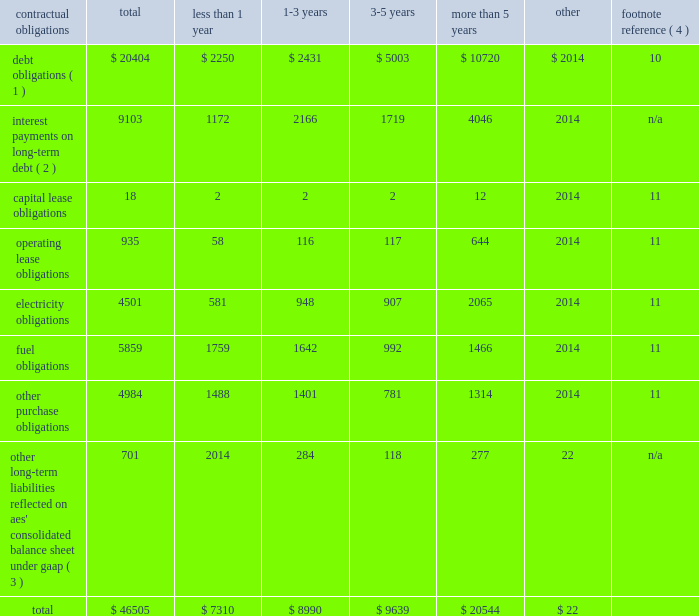2022 triggering our obligation to make payments under any financial guarantee , letter of credit or other credit support we have provided to or on behalf of such subsidiary ; 2022 causing us to record a loss in the event the lender forecloses on the assets ; and 2022 triggering defaults in our outstanding debt at the parent company .
For example , our senior secured credit facility and outstanding debt securities at the parent company include events of default for certain bankruptcy related events involving material subsidiaries .
In addition , our revolving credit agreement at the parent company includes events of default related to payment defaults and accelerations of outstanding debt of material subsidiaries .
Some of our subsidiaries are currently in default with respect to all or a portion of their outstanding indebtedness .
The total non-recourse debt classified as current in the accompanying consolidated balance sheets amounts to $ 2.2 billion .
The portion of current debt related to such defaults was $ 1 billion at december 31 , 2017 , all of which was non-recourse debt related to three subsidiaries 2014 alto maipo , aes puerto rico , and aes ilumina .
See note 10 2014debt in item 8 . 2014financial statements and supplementary data of this form 10-k for additional detail .
None of the subsidiaries that are currently in default are subsidiaries that met the applicable definition of materiality under aes' corporate debt agreements as of december 31 , 2017 in order for such defaults to trigger an event of default or permit acceleration under aes' indebtedness .
However , as a result of additional dispositions of assets , other significant reductions in asset carrying values or other matters in the future that may impact our financial position and results of operations or the financial position of the individual subsidiary , it is possible that one or more of these subsidiaries could fall within the definition of a "material subsidiary" and thereby upon an acceleration trigger an event of default and possible acceleration of the indebtedness under the parent company's outstanding debt securities .
A material subsidiary is defined in the company's senior secured revolving credit facility as any business that contributed 20% ( 20 % ) or more of the parent company's total cash distributions from businesses for the four most recently completed fiscal quarters .
As of december 31 , 2017 , none of the defaults listed above individually or in the aggregate results in or is at risk of triggering a cross-default under the recourse debt of the company .
Contractual obligations and parent company contingent contractual obligations a summary of our contractual obligations , commitments and other liabilities as of december 31 , 2017 is presented below and excludes any businesses classified as discontinued operations or held-for-sale ( in millions ) : contractual obligations total less than 1 year more than 5 years other footnote reference ( 4 ) debt obligations ( 1 ) $ 20404 $ 2250 $ 2431 $ 5003 $ 10720 $ 2014 10 interest payments on long-term debt ( 2 ) 9103 1172 2166 1719 4046 2014 n/a .
_____________________________ ( 1 ) includes recourse and non-recourse debt presented on the consolidated balance sheet .
These amounts exclude capital lease obligations which are included in the capital lease category .
( 2 ) interest payments are estimated based on final maturity dates of debt securities outstanding at december 31 , 2017 and do not reflect anticipated future refinancing , early redemptions or new debt issuances .
Variable rate interest obligations are estimated based on rates as of december 31 , 2017 .
( 3 ) these amounts do not include current liabilities on the consolidated balance sheet except for the current portion of uncertain tax obligations .
Noncurrent uncertain tax obligations are reflected in the "other" column of the table above as the company is not able to reasonably estimate the timing of the future payments .
In addition , these amounts do not include : ( 1 ) regulatory liabilities ( see note 9 2014regulatory assets and liabilities ) , ( 2 ) contingencies ( see note 12 2014contingencies ) , ( 3 ) pension and other postretirement employee benefit liabilities ( see note 13 2014benefit plans ) , ( 4 ) derivatives and incentive compensation ( see note 5 2014derivative instruments and hedging activities ) or ( 5 ) any taxes ( see note 20 2014income taxes ) except for uncertain tax obligations , as the company is not able to reasonably estimate the timing of future payments .
See the indicated notes to the consolidated financial statements included in item 8 of this form 10-k for additional information on the items excluded .
( 4 ) for further information see the note referenced below in item 8 . 2014financial statements and supplementary data of this form 10-k. .
What percentage of total contractual obligations , commitments and other liabilities as of december 31 , 2017 is composed of fuel obligations? 
Computations: (5859 / 46505)
Answer: 0.12599. 